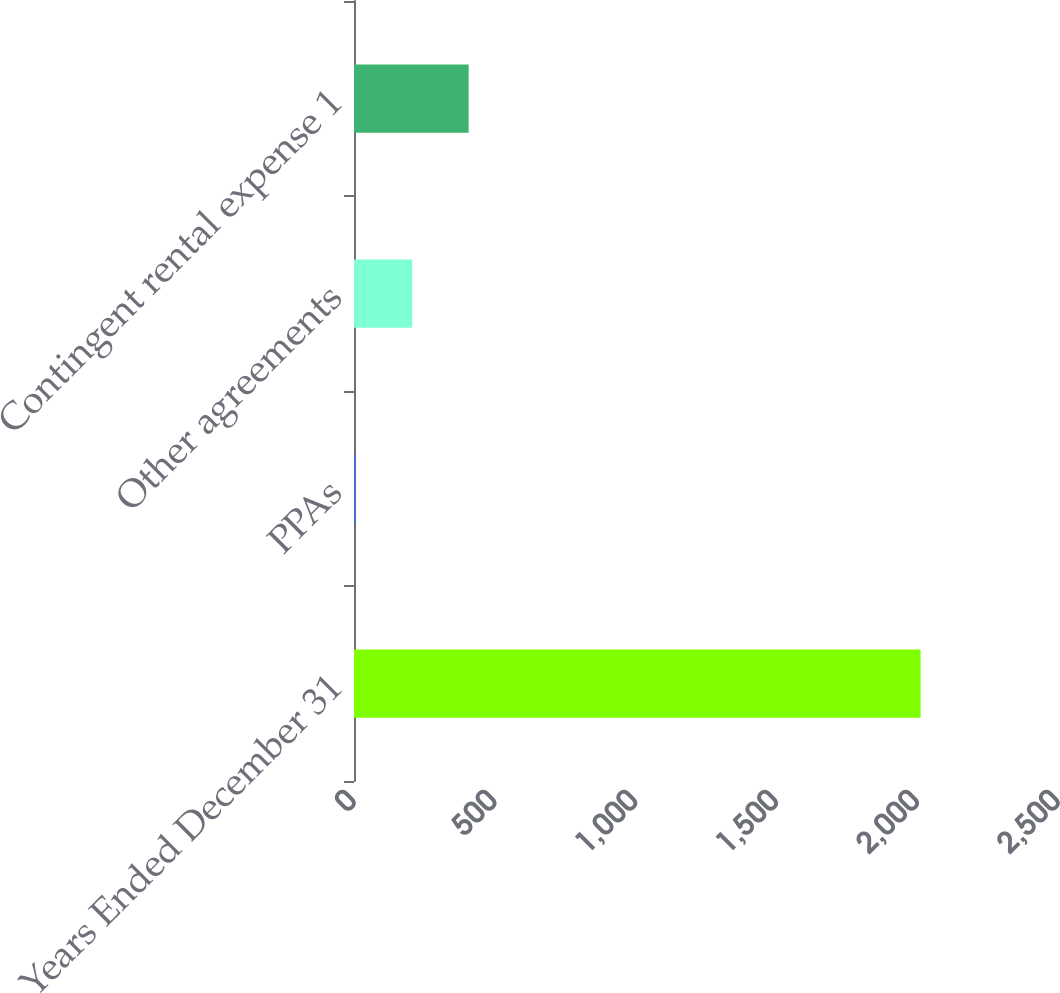<chart> <loc_0><loc_0><loc_500><loc_500><bar_chart><fcel>Years Ended December 31<fcel>PPAs<fcel>Other agreements<fcel>Contingent rental expense 1<nl><fcel>2012<fcel>6<fcel>206.6<fcel>407.2<nl></chart> 